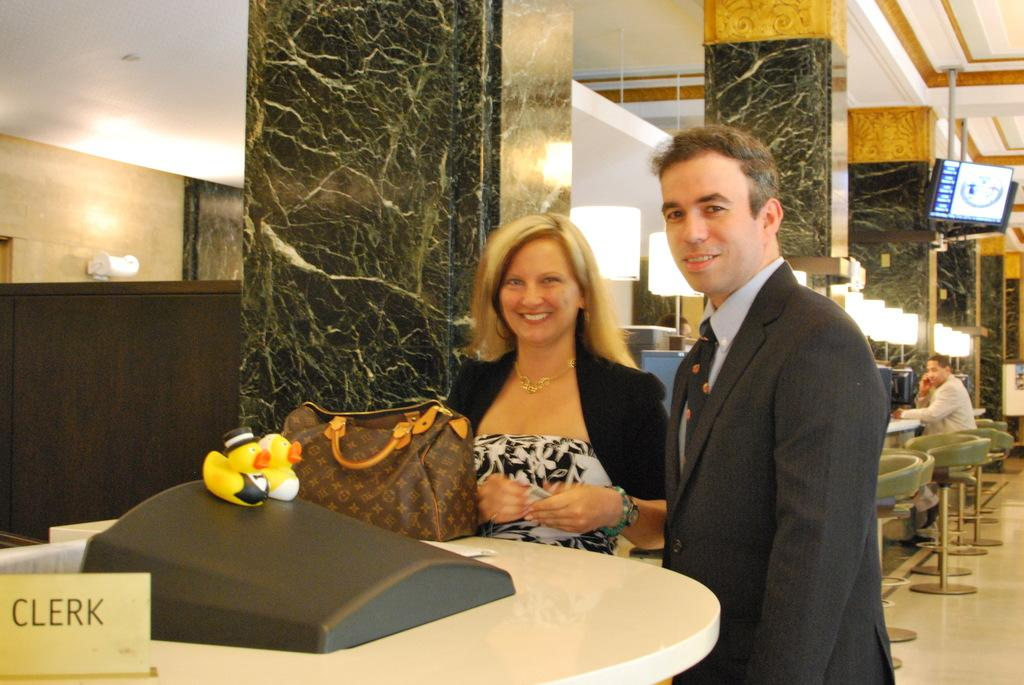How many people are in the image? There are two people in the image, a man and a woman. What are the man and woman doing in the image? The man and woman are standing beside each other in the image. What is located behind the man and woman? They are standing in front of a table. What type of location might this image be taken in? The setting appears to be in a hotel. What type of credit card is the man holding in the image? There is no credit card visible in the image. How many dolls are sitting on the table in the image? There are no dolls present in the image. 